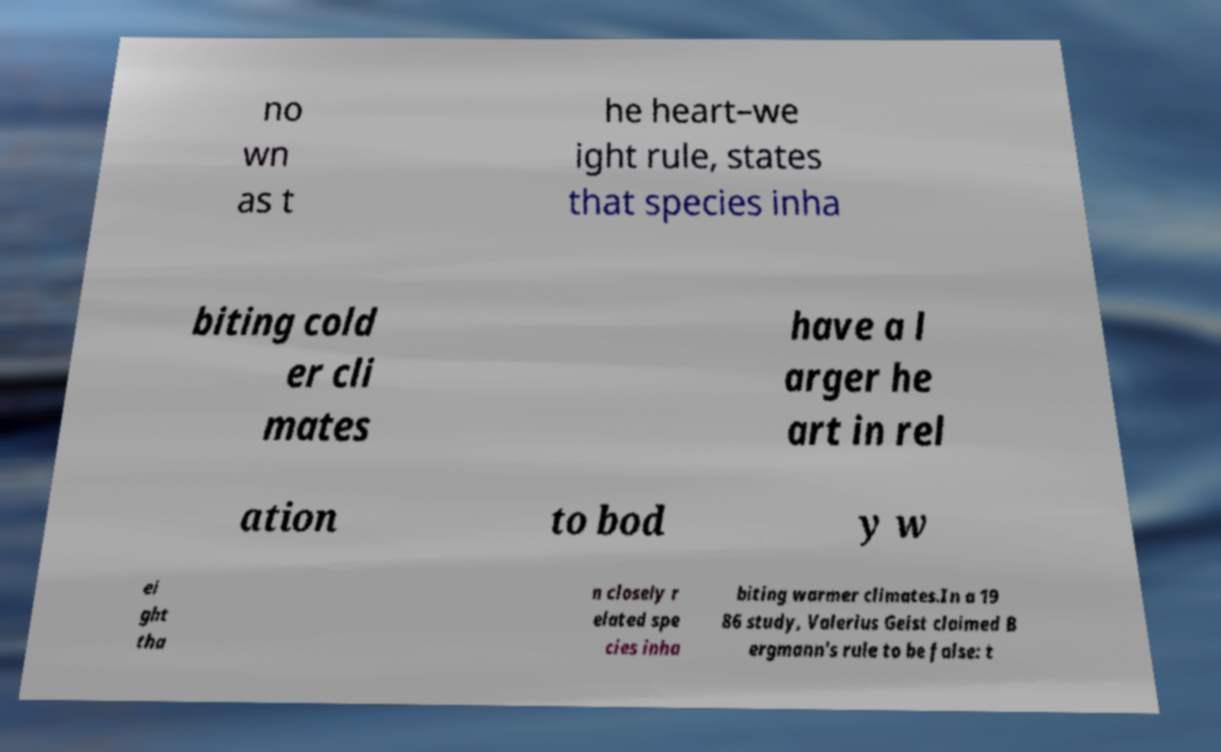Could you assist in decoding the text presented in this image and type it out clearly? no wn as t he heart–we ight rule, states that species inha biting cold er cli mates have a l arger he art in rel ation to bod y w ei ght tha n closely r elated spe cies inha biting warmer climates.In a 19 86 study, Valerius Geist claimed B ergmann's rule to be false: t 